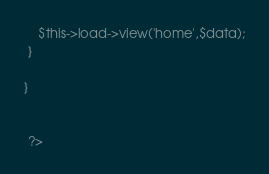Convert code to text. <code><loc_0><loc_0><loc_500><loc_500><_PHP_>    $this->load->view('home',$data);
 }

}


 ?></code> 